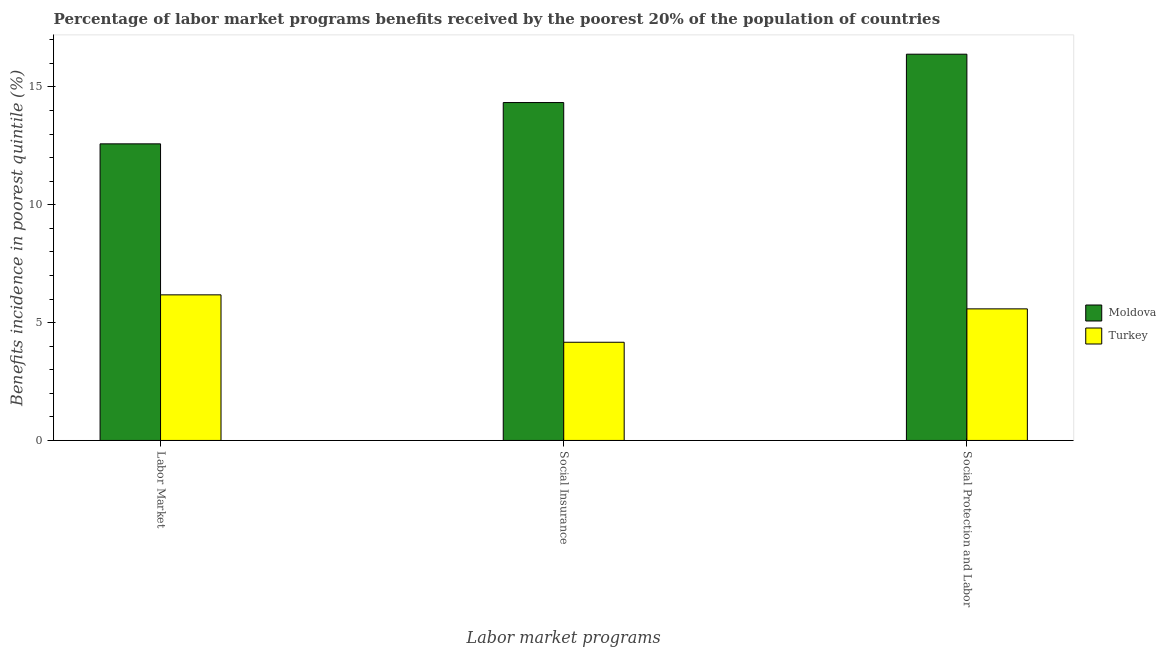How many different coloured bars are there?
Offer a very short reply. 2. How many bars are there on the 1st tick from the left?
Keep it short and to the point. 2. What is the label of the 3rd group of bars from the left?
Your answer should be very brief. Social Protection and Labor. What is the percentage of benefits received due to social protection programs in Moldova?
Ensure brevity in your answer.  16.39. Across all countries, what is the maximum percentage of benefits received due to social insurance programs?
Offer a very short reply. 14.33. Across all countries, what is the minimum percentage of benefits received due to labor market programs?
Ensure brevity in your answer.  6.18. In which country was the percentage of benefits received due to social insurance programs maximum?
Ensure brevity in your answer.  Moldova. In which country was the percentage of benefits received due to social insurance programs minimum?
Offer a very short reply. Turkey. What is the total percentage of benefits received due to labor market programs in the graph?
Offer a terse response. 18.76. What is the difference between the percentage of benefits received due to social insurance programs in Turkey and that in Moldova?
Provide a short and direct response. -10.17. What is the difference between the percentage of benefits received due to social protection programs in Turkey and the percentage of benefits received due to social insurance programs in Moldova?
Keep it short and to the point. -8.75. What is the average percentage of benefits received due to social insurance programs per country?
Your answer should be compact. 9.25. What is the difference between the percentage of benefits received due to social protection programs and percentage of benefits received due to social insurance programs in Moldova?
Provide a short and direct response. 2.05. In how many countries, is the percentage of benefits received due to social protection programs greater than 1 %?
Your response must be concise. 2. What is the ratio of the percentage of benefits received due to labor market programs in Moldova to that in Turkey?
Offer a terse response. 2.04. Is the percentage of benefits received due to labor market programs in Turkey less than that in Moldova?
Provide a succinct answer. Yes. Is the difference between the percentage of benefits received due to labor market programs in Turkey and Moldova greater than the difference between the percentage of benefits received due to social protection programs in Turkey and Moldova?
Make the answer very short. Yes. What is the difference between the highest and the second highest percentage of benefits received due to labor market programs?
Offer a very short reply. 6.41. What is the difference between the highest and the lowest percentage of benefits received due to social protection programs?
Keep it short and to the point. 10.81. Is the sum of the percentage of benefits received due to social insurance programs in Moldova and Turkey greater than the maximum percentage of benefits received due to labor market programs across all countries?
Keep it short and to the point. Yes. What does the 2nd bar from the left in Social Protection and Labor represents?
Your answer should be compact. Turkey. Is it the case that in every country, the sum of the percentage of benefits received due to labor market programs and percentage of benefits received due to social insurance programs is greater than the percentage of benefits received due to social protection programs?
Your answer should be compact. Yes. How many bars are there?
Offer a very short reply. 6. Are the values on the major ticks of Y-axis written in scientific E-notation?
Make the answer very short. No. Does the graph contain any zero values?
Your answer should be very brief. No. Does the graph contain grids?
Ensure brevity in your answer.  No. How many legend labels are there?
Ensure brevity in your answer.  2. What is the title of the graph?
Offer a terse response. Percentage of labor market programs benefits received by the poorest 20% of the population of countries. Does "Japan" appear as one of the legend labels in the graph?
Your answer should be very brief. No. What is the label or title of the X-axis?
Provide a succinct answer. Labor market programs. What is the label or title of the Y-axis?
Offer a terse response. Benefits incidence in poorest quintile (%). What is the Benefits incidence in poorest quintile (%) of Moldova in Labor Market?
Keep it short and to the point. 12.58. What is the Benefits incidence in poorest quintile (%) in Turkey in Labor Market?
Keep it short and to the point. 6.18. What is the Benefits incidence in poorest quintile (%) of Moldova in Social Insurance?
Offer a terse response. 14.33. What is the Benefits incidence in poorest quintile (%) of Turkey in Social Insurance?
Offer a terse response. 4.17. What is the Benefits incidence in poorest quintile (%) in Moldova in Social Protection and Labor?
Offer a terse response. 16.39. What is the Benefits incidence in poorest quintile (%) of Turkey in Social Protection and Labor?
Give a very brief answer. 5.58. Across all Labor market programs, what is the maximum Benefits incidence in poorest quintile (%) in Moldova?
Make the answer very short. 16.39. Across all Labor market programs, what is the maximum Benefits incidence in poorest quintile (%) of Turkey?
Your answer should be compact. 6.18. Across all Labor market programs, what is the minimum Benefits incidence in poorest quintile (%) of Moldova?
Offer a very short reply. 12.58. Across all Labor market programs, what is the minimum Benefits incidence in poorest quintile (%) in Turkey?
Offer a terse response. 4.17. What is the total Benefits incidence in poorest quintile (%) in Moldova in the graph?
Offer a very short reply. 43.3. What is the total Benefits incidence in poorest quintile (%) of Turkey in the graph?
Provide a short and direct response. 15.92. What is the difference between the Benefits incidence in poorest quintile (%) of Moldova in Labor Market and that in Social Insurance?
Give a very brief answer. -1.75. What is the difference between the Benefits incidence in poorest quintile (%) of Turkey in Labor Market and that in Social Insurance?
Provide a succinct answer. 2.01. What is the difference between the Benefits incidence in poorest quintile (%) in Moldova in Labor Market and that in Social Protection and Labor?
Keep it short and to the point. -3.8. What is the difference between the Benefits incidence in poorest quintile (%) of Turkey in Labor Market and that in Social Protection and Labor?
Your response must be concise. 0.59. What is the difference between the Benefits incidence in poorest quintile (%) of Moldova in Social Insurance and that in Social Protection and Labor?
Provide a short and direct response. -2.05. What is the difference between the Benefits incidence in poorest quintile (%) of Turkey in Social Insurance and that in Social Protection and Labor?
Your answer should be compact. -1.42. What is the difference between the Benefits incidence in poorest quintile (%) in Moldova in Labor Market and the Benefits incidence in poorest quintile (%) in Turkey in Social Insurance?
Offer a terse response. 8.42. What is the difference between the Benefits incidence in poorest quintile (%) in Moldova in Labor Market and the Benefits incidence in poorest quintile (%) in Turkey in Social Protection and Labor?
Your response must be concise. 7. What is the difference between the Benefits incidence in poorest quintile (%) of Moldova in Social Insurance and the Benefits incidence in poorest quintile (%) of Turkey in Social Protection and Labor?
Offer a terse response. 8.75. What is the average Benefits incidence in poorest quintile (%) of Moldova per Labor market programs?
Provide a succinct answer. 14.44. What is the average Benefits incidence in poorest quintile (%) in Turkey per Labor market programs?
Provide a succinct answer. 5.31. What is the difference between the Benefits incidence in poorest quintile (%) in Moldova and Benefits incidence in poorest quintile (%) in Turkey in Labor Market?
Ensure brevity in your answer.  6.41. What is the difference between the Benefits incidence in poorest quintile (%) of Moldova and Benefits incidence in poorest quintile (%) of Turkey in Social Insurance?
Provide a short and direct response. 10.17. What is the difference between the Benefits incidence in poorest quintile (%) in Moldova and Benefits incidence in poorest quintile (%) in Turkey in Social Protection and Labor?
Your answer should be very brief. 10.8. What is the ratio of the Benefits incidence in poorest quintile (%) of Moldova in Labor Market to that in Social Insurance?
Offer a terse response. 0.88. What is the ratio of the Benefits incidence in poorest quintile (%) in Turkey in Labor Market to that in Social Insurance?
Your answer should be compact. 1.48. What is the ratio of the Benefits incidence in poorest quintile (%) of Moldova in Labor Market to that in Social Protection and Labor?
Offer a terse response. 0.77. What is the ratio of the Benefits incidence in poorest quintile (%) of Turkey in Labor Market to that in Social Protection and Labor?
Give a very brief answer. 1.11. What is the ratio of the Benefits incidence in poorest quintile (%) of Moldova in Social Insurance to that in Social Protection and Labor?
Your answer should be very brief. 0.87. What is the ratio of the Benefits incidence in poorest quintile (%) in Turkey in Social Insurance to that in Social Protection and Labor?
Give a very brief answer. 0.75. What is the difference between the highest and the second highest Benefits incidence in poorest quintile (%) of Moldova?
Your response must be concise. 2.05. What is the difference between the highest and the second highest Benefits incidence in poorest quintile (%) of Turkey?
Provide a succinct answer. 0.59. What is the difference between the highest and the lowest Benefits incidence in poorest quintile (%) in Moldova?
Make the answer very short. 3.8. What is the difference between the highest and the lowest Benefits incidence in poorest quintile (%) of Turkey?
Offer a very short reply. 2.01. 